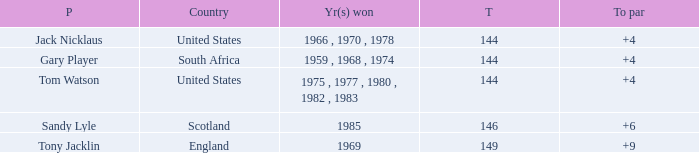What was England's total? 149.0. 